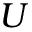<formula> <loc_0><loc_0><loc_500><loc_500>U</formula> 